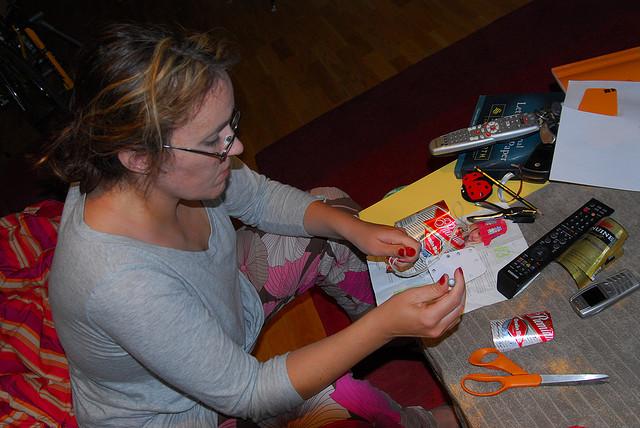What room is pictured with a bed?
Keep it brief. Bedroom. What is in the small yellow box?
Write a very short answer. Paper. What event is being celebrated here?
Be succinct. Birthday. What color are the scissors?
Write a very short answer. Orange. Who is this girl talking to?
Concise answer only. No one. What is the woman wearing?
Keep it brief. Shirt. Is someone going on a journey?
Be succinct. No. What is in the woman's hand?
Short answer required. Paper. Could she be from the Middle-East?
Concise answer only. No. What is the person holding?
Be succinct. Paper. Is this girl using a pen or pencil?
Answer briefly. Pen. How many pencils are on the table?
Short answer required. 1. What color is the tablecloth?
Be succinct. Gray. How many people in the photo?
Concise answer only. 1. Is this an adult or child?
Be succinct. Adult. How many remotes are on the table?
Write a very short answer. 2. What color shirt is the woman wearing?
Be succinct. Gray. Is the woman wearing a necklace?
Write a very short answer. No. Is this woman wearing eye makeup?
Give a very brief answer. No. Can you guess what this girl is currently entertaining herself with?
Keep it brief. Crafts. What color is the floor?
Keep it brief. Brown. What attitude is this person expressing?
Quick response, please. Concentration. 